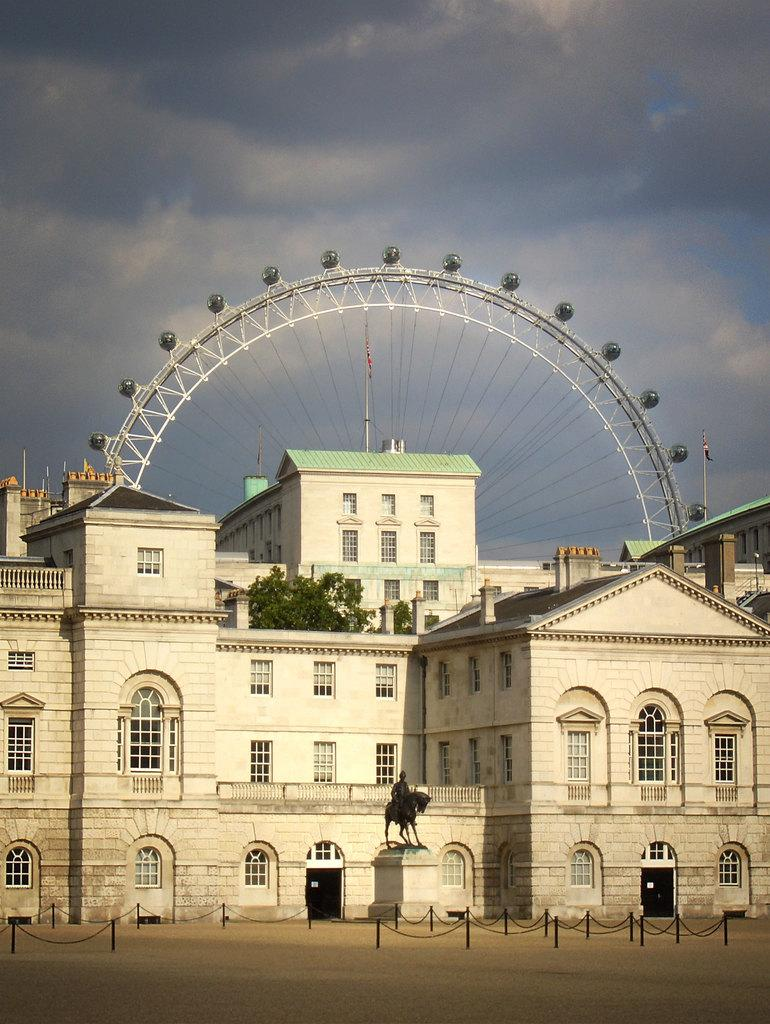What is the main structure in the middle of the picture? There is a building in the middle of the picture. What can be seen in the background of the image? There is a giant wheel and clouds visible in the sky in the background of the image. What type of chalk is being used to draw on the building in the image? There is no chalk or drawing present on the building in the image. What direction is the building facing in the image? The direction the building is facing cannot be determined from the image alone. 